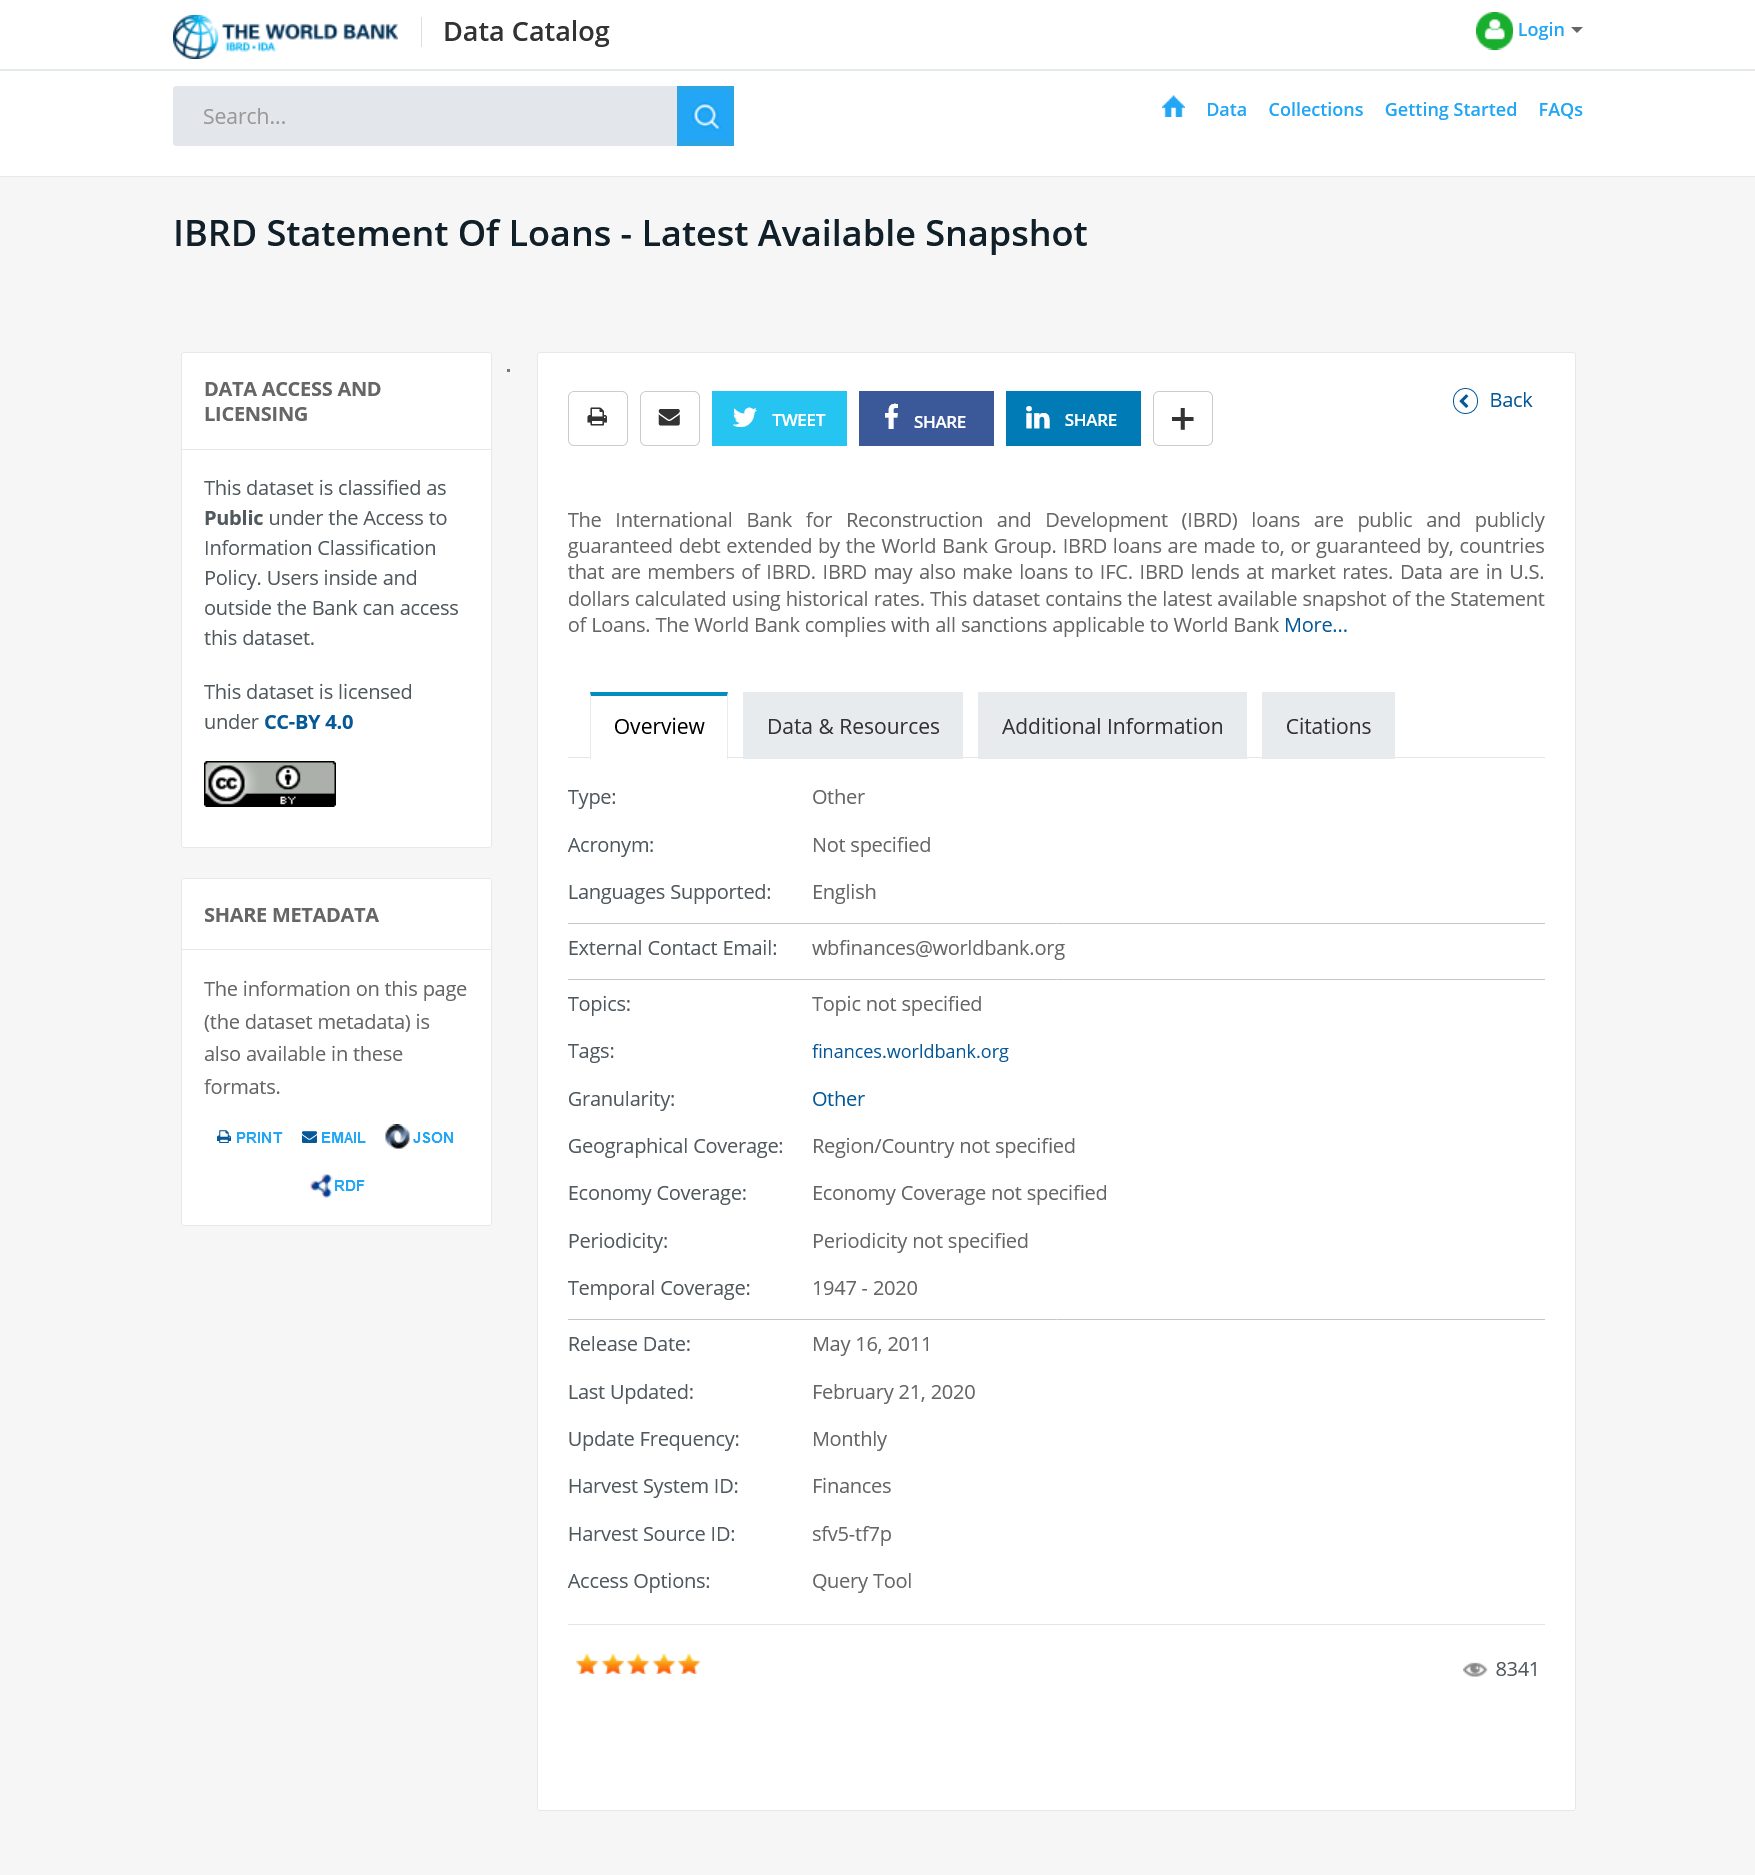Mention a couple of crucial points in this snapshot. The International Bank for Reconstruction and Development is commonly referred to as IBRD. The International Finance Corporation (IFC) is authorized to make loans to individuals and entities, while the International Bank for Reconstruction and Development (IBRD) is restricted to making loans to governments and official entities. 